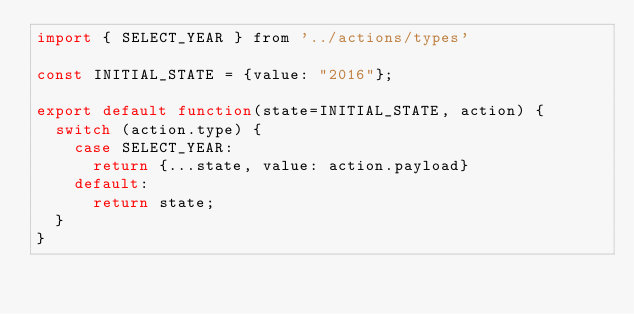<code> <loc_0><loc_0><loc_500><loc_500><_JavaScript_>import { SELECT_YEAR } from '../actions/types'

const INITIAL_STATE = {value: "2016"};

export default function(state=INITIAL_STATE, action) {
  switch (action.type) {
    case SELECT_YEAR:
      return {...state, value: action.payload}
    default:
      return state;
  }
}
</code> 